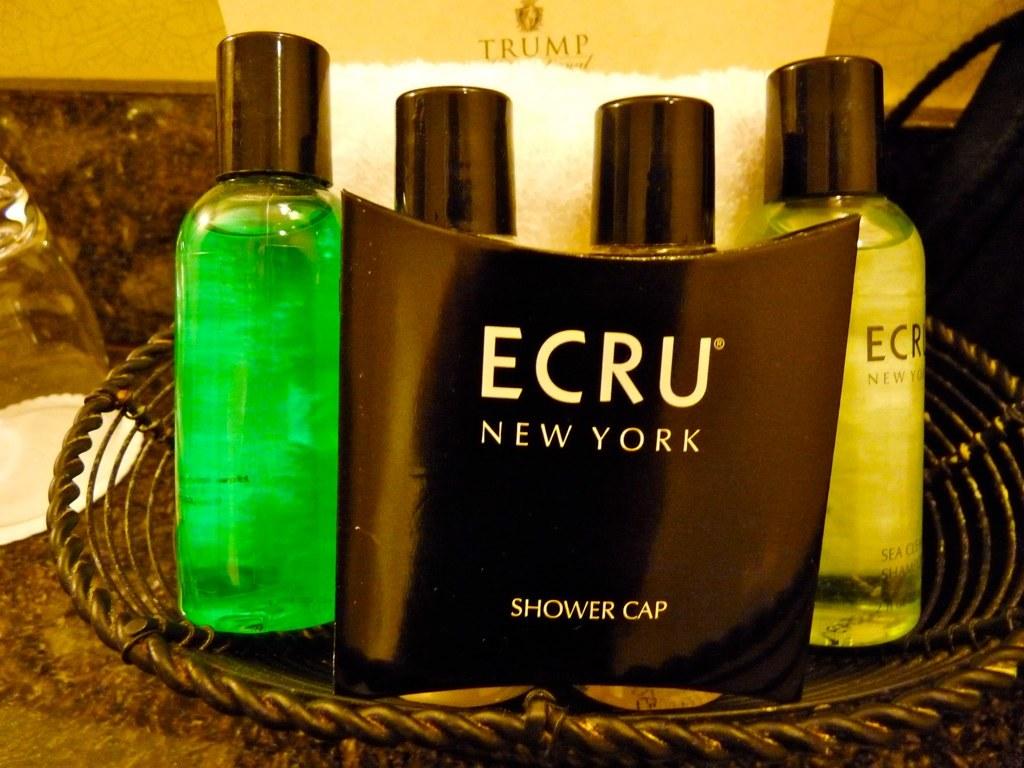What is in the box?
Your response must be concise. Shower cap. 